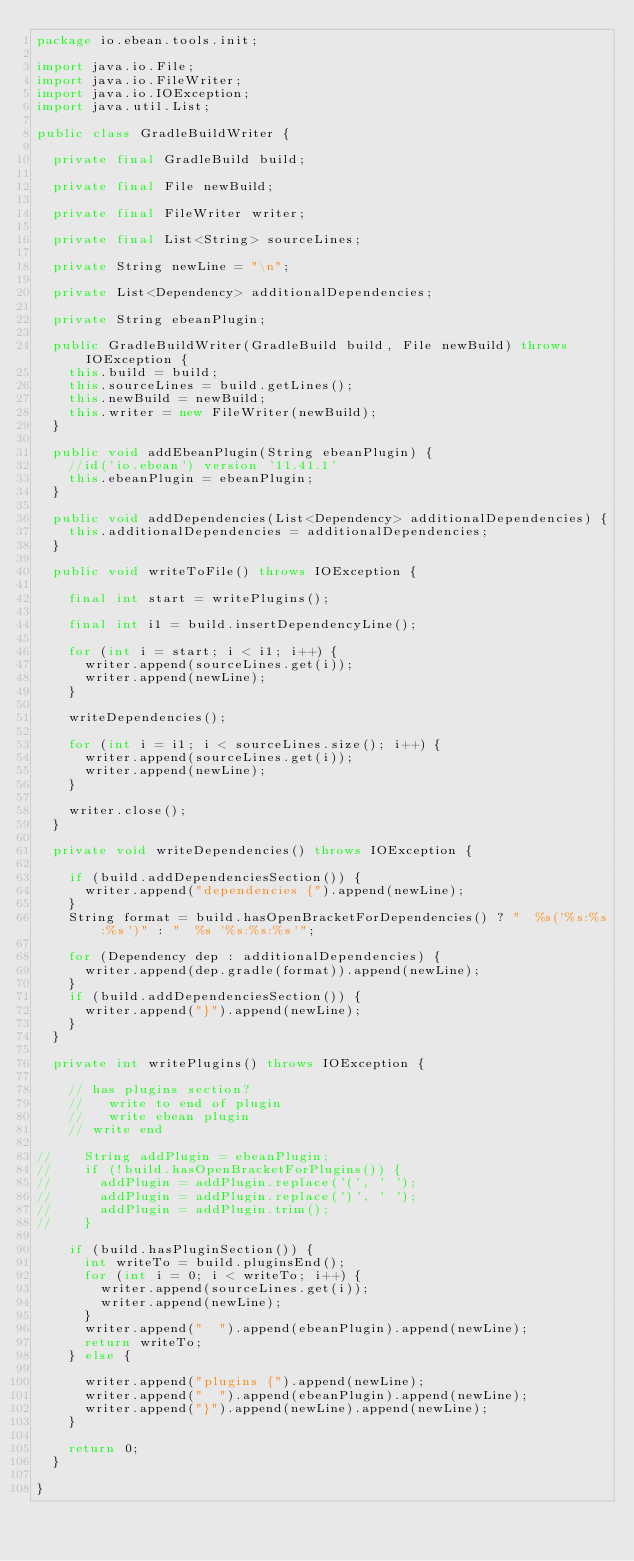Convert code to text. <code><loc_0><loc_0><loc_500><loc_500><_Java_>package io.ebean.tools.init;

import java.io.File;
import java.io.FileWriter;
import java.io.IOException;
import java.util.List;

public class GradleBuildWriter {

  private final GradleBuild build;

  private final File newBuild;

  private final FileWriter writer;

  private final List<String> sourceLines;

  private String newLine = "\n";

  private List<Dependency> additionalDependencies;

  private String ebeanPlugin;

  public GradleBuildWriter(GradleBuild build, File newBuild) throws IOException {
    this.build = build;
    this.sourceLines = build.getLines();
    this.newBuild = newBuild;
    this.writer = new FileWriter(newBuild);
  }

  public void addEbeanPlugin(String ebeanPlugin) {
    //id('io.ebean') version '11.41.1'
    this.ebeanPlugin = ebeanPlugin;
  }

  public void addDependencies(List<Dependency> additionalDependencies) {
    this.additionalDependencies = additionalDependencies;
  }

  public void writeToFile() throws IOException {

    final int start = writePlugins();

    final int i1 = build.insertDependencyLine();

    for (int i = start; i < i1; i++) {
      writer.append(sourceLines.get(i));
      writer.append(newLine);
    }

    writeDependencies();

    for (int i = i1; i < sourceLines.size(); i++) {
      writer.append(sourceLines.get(i));
      writer.append(newLine);
    }

    writer.close();
  }

  private void writeDependencies() throws IOException {

    if (build.addDependenciesSection()) {
      writer.append("dependencies {").append(newLine);
    }
    String format = build.hasOpenBracketForDependencies() ? "  %s('%s:%s:%s')" : "  %s '%s:%s:%s'";

    for (Dependency dep : additionalDependencies) {
      writer.append(dep.gradle(format)).append(newLine);
    }
    if (build.addDependenciesSection()) {
      writer.append("}").append(newLine);
    }
  }

  private int writePlugins() throws IOException {

    // has plugins section?
    //   write to end of plugin
    //   write ebean plugin
    // write end

//    String addPlugin = ebeanPlugin;
//    if (!build.hasOpenBracketForPlugins()) {
//      addPlugin = addPlugin.replace('(', ' ');
//      addPlugin = addPlugin.replace(')', ' ');
//      addPlugin = addPlugin.trim();
//    }

    if (build.hasPluginSection()) {
      int writeTo = build.pluginsEnd();
      for (int i = 0; i < writeTo; i++) {
        writer.append(sourceLines.get(i));
        writer.append(newLine);
      }
      writer.append("  ").append(ebeanPlugin).append(newLine);
      return writeTo;
    } else {

      writer.append("plugins {").append(newLine);
      writer.append("  ").append(ebeanPlugin).append(newLine);
      writer.append("}").append(newLine).append(newLine);
    }

    return 0;
  }

}
</code> 